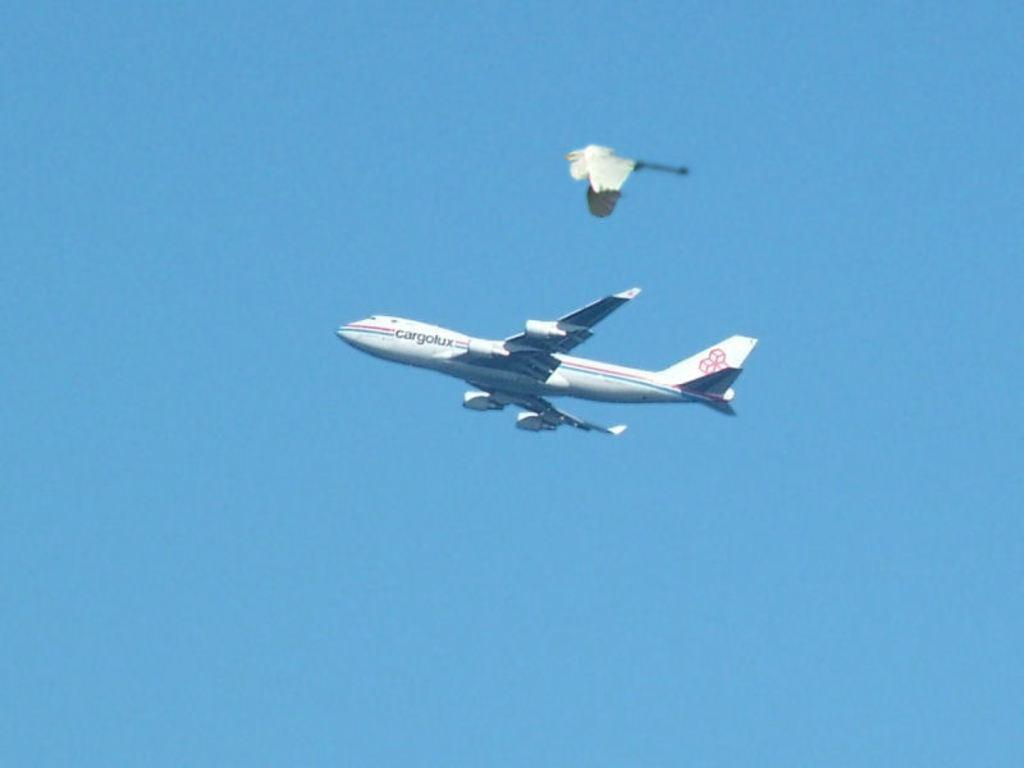Please provide a concise description of this image. In the image there is an aircraft flying in the air, above the aircraft it looks like there is a bird also flying in the air. 